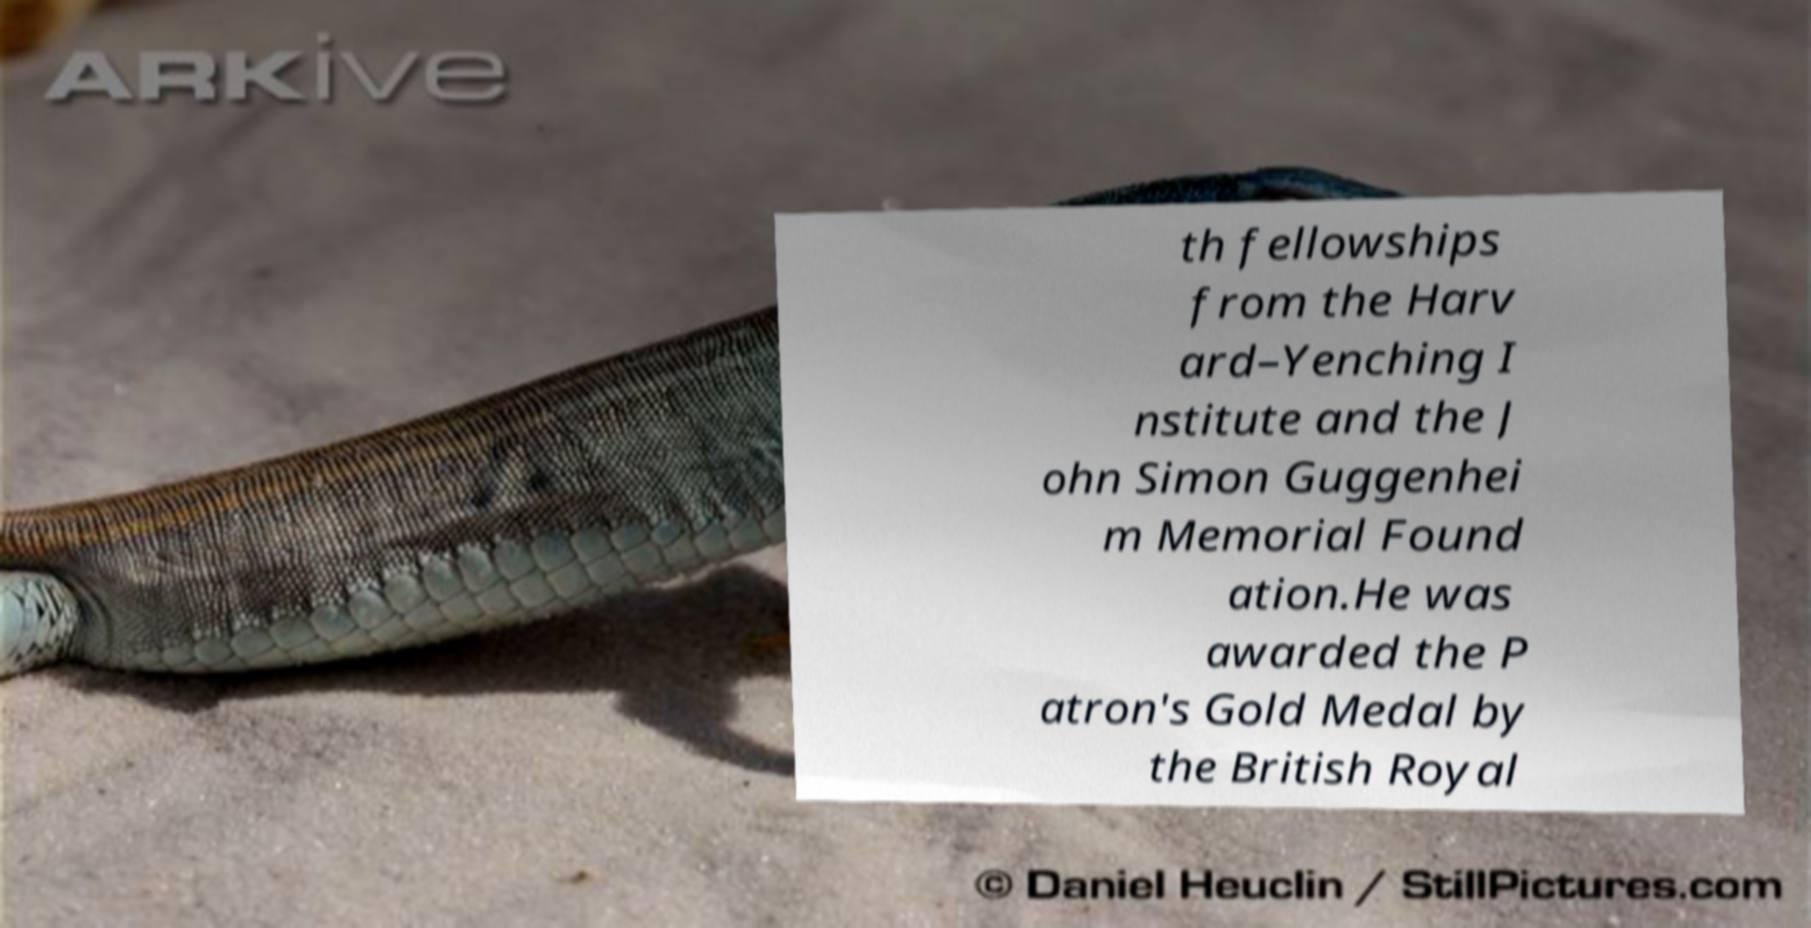What messages or text are displayed in this image? I need them in a readable, typed format. th fellowships from the Harv ard–Yenching I nstitute and the J ohn Simon Guggenhei m Memorial Found ation.He was awarded the P atron's Gold Medal by the British Royal 